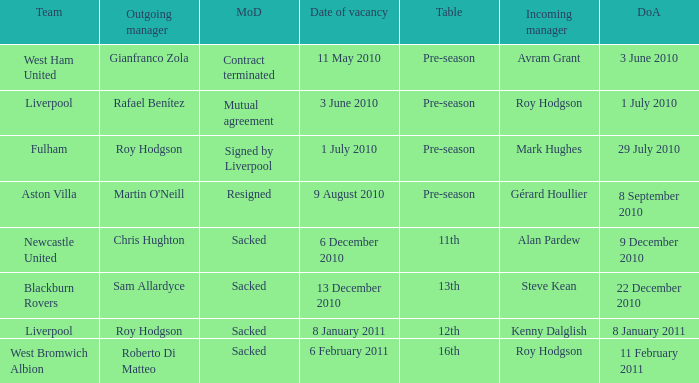What team has an incoming manager named Kenny Dalglish? Liverpool. 